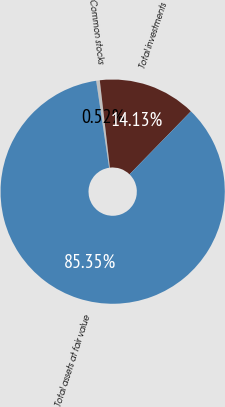<chart> <loc_0><loc_0><loc_500><loc_500><pie_chart><fcel>Common stocks<fcel>Total investments<fcel>Total assets at fair value<nl><fcel>0.52%<fcel>14.13%<fcel>85.36%<nl></chart> 